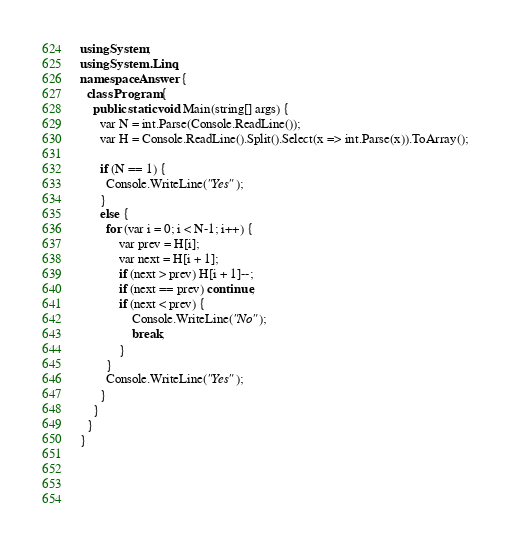Convert code to text. <code><loc_0><loc_0><loc_500><loc_500><_C#_>using System;
using System.Linq;
namespace Answer {
  class Program {
    public static void Main(string[] args) {
      var N = int.Parse(Console.ReadLine());
      var H = Console.ReadLine().Split().Select(x => int.Parse(x)).ToArray();
      
      if (N == 1) { 
        Console.WriteLine("Yes");
      }
      else {
        for (var i = 0; i < N-1; i++) {
        	var prev = H[i];
        	var next = H[i + 1];
        	if (next > prev) H[i + 1]--;
        	if (next == prev) continue;
        	if (next < prev) {
          		Console.WriteLine("No");
          		break;
        	}
      	}
        Console.WriteLine("Yes");
      }
    }
  }
}
        
        
        
      
</code> 